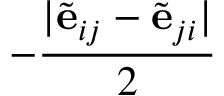<formula> <loc_0><loc_0><loc_500><loc_500>- \frac { | \tilde { e } _ { i j } - \tilde { e } _ { j i } | } { 2 }</formula> 